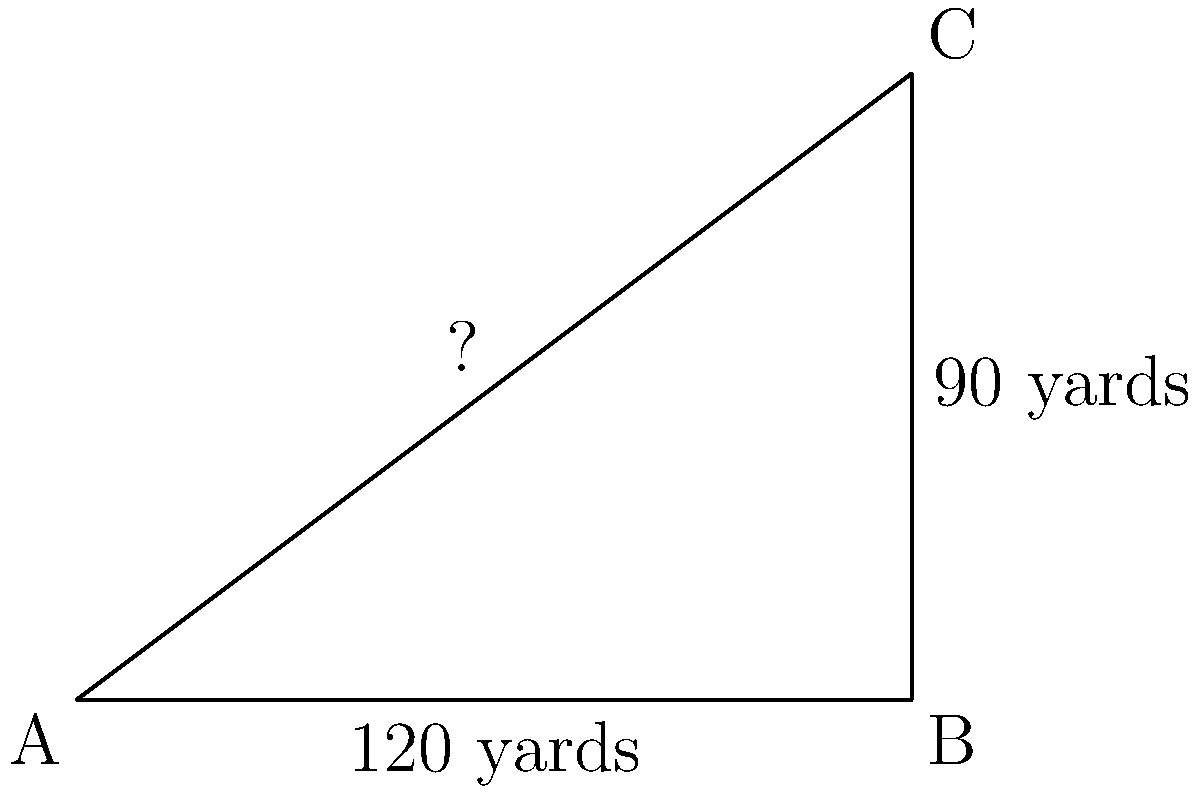During a practice session, you need to run diagonally across the football field from one corner to the opposite corner. Given that the field is 120 yards long and 90 yards wide, how many yards will you cover in this diagonal run? Round your answer to the nearest yard. To solve this problem, we'll use the Pythagorean theorem, which states that in a right triangle, the square of the length of the hypotenuse is equal to the sum of squares of the other two sides.

Let's approach this step-by-step:

1) Let's denote the diagonal distance as $d$.

2) We know the length of the field is 120 yards and the width is 90 yards.

3) According to the Pythagorean theorem:
   $d^2 = 120^2 + 90^2$

4) Let's calculate the right side:
   $d^2 = 14400 + 8100 = 22500$

5) Now, to find $d$, we need to take the square root of both sides:
   $d = \sqrt{22500}$

6) Calculate this:
   $d \approx 150$ yards (rounded to the nearest yard)

Therefore, you will cover approximately 150 yards in your diagonal run across the football field.
Answer: 150 yards 